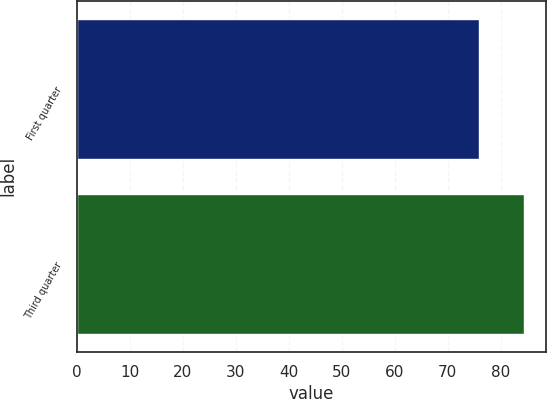<chart> <loc_0><loc_0><loc_500><loc_500><bar_chart><fcel>First quarter<fcel>Third quarter<nl><fcel>75.97<fcel>84.35<nl></chart> 